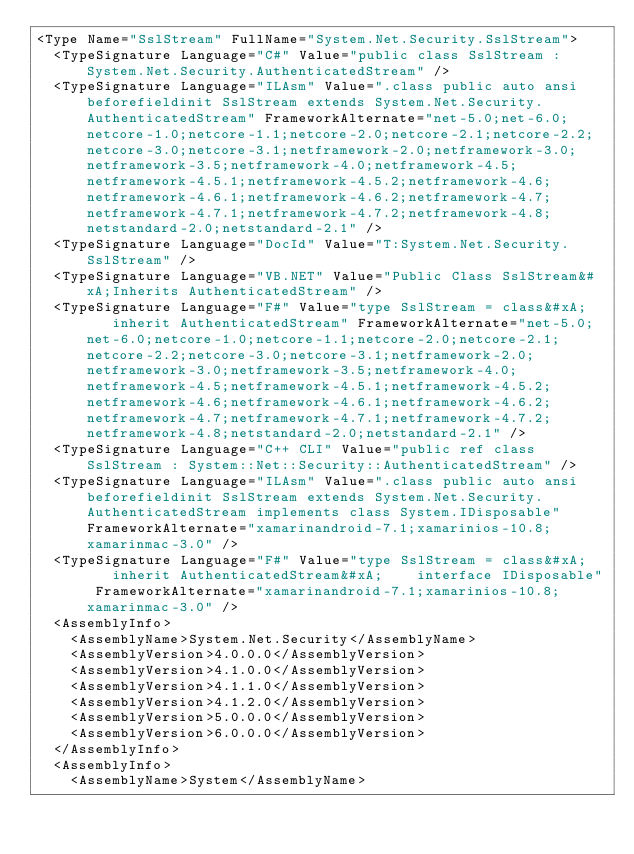<code> <loc_0><loc_0><loc_500><loc_500><_XML_><Type Name="SslStream" FullName="System.Net.Security.SslStream">
  <TypeSignature Language="C#" Value="public class SslStream : System.Net.Security.AuthenticatedStream" />
  <TypeSignature Language="ILAsm" Value=".class public auto ansi beforefieldinit SslStream extends System.Net.Security.AuthenticatedStream" FrameworkAlternate="net-5.0;net-6.0;netcore-1.0;netcore-1.1;netcore-2.0;netcore-2.1;netcore-2.2;netcore-3.0;netcore-3.1;netframework-2.0;netframework-3.0;netframework-3.5;netframework-4.0;netframework-4.5;netframework-4.5.1;netframework-4.5.2;netframework-4.6;netframework-4.6.1;netframework-4.6.2;netframework-4.7;netframework-4.7.1;netframework-4.7.2;netframework-4.8;netstandard-2.0;netstandard-2.1" />
  <TypeSignature Language="DocId" Value="T:System.Net.Security.SslStream" />
  <TypeSignature Language="VB.NET" Value="Public Class SslStream&#xA;Inherits AuthenticatedStream" />
  <TypeSignature Language="F#" Value="type SslStream = class&#xA;    inherit AuthenticatedStream" FrameworkAlternate="net-5.0;net-6.0;netcore-1.0;netcore-1.1;netcore-2.0;netcore-2.1;netcore-2.2;netcore-3.0;netcore-3.1;netframework-2.0;netframework-3.0;netframework-3.5;netframework-4.0;netframework-4.5;netframework-4.5.1;netframework-4.5.2;netframework-4.6;netframework-4.6.1;netframework-4.6.2;netframework-4.7;netframework-4.7.1;netframework-4.7.2;netframework-4.8;netstandard-2.0;netstandard-2.1" />
  <TypeSignature Language="C++ CLI" Value="public ref class SslStream : System::Net::Security::AuthenticatedStream" />
  <TypeSignature Language="ILAsm" Value=".class public auto ansi beforefieldinit SslStream extends System.Net.Security.AuthenticatedStream implements class System.IDisposable" FrameworkAlternate="xamarinandroid-7.1;xamarinios-10.8;xamarinmac-3.0" />
  <TypeSignature Language="F#" Value="type SslStream = class&#xA;    inherit AuthenticatedStream&#xA;    interface IDisposable" FrameworkAlternate="xamarinandroid-7.1;xamarinios-10.8;xamarinmac-3.0" />
  <AssemblyInfo>
    <AssemblyName>System.Net.Security</AssemblyName>
    <AssemblyVersion>4.0.0.0</AssemblyVersion>
    <AssemblyVersion>4.1.0.0</AssemblyVersion>
    <AssemblyVersion>4.1.1.0</AssemblyVersion>
    <AssemblyVersion>4.1.2.0</AssemblyVersion>
    <AssemblyVersion>5.0.0.0</AssemblyVersion>
    <AssemblyVersion>6.0.0.0</AssemblyVersion>
  </AssemblyInfo>
  <AssemblyInfo>
    <AssemblyName>System</AssemblyName></code> 